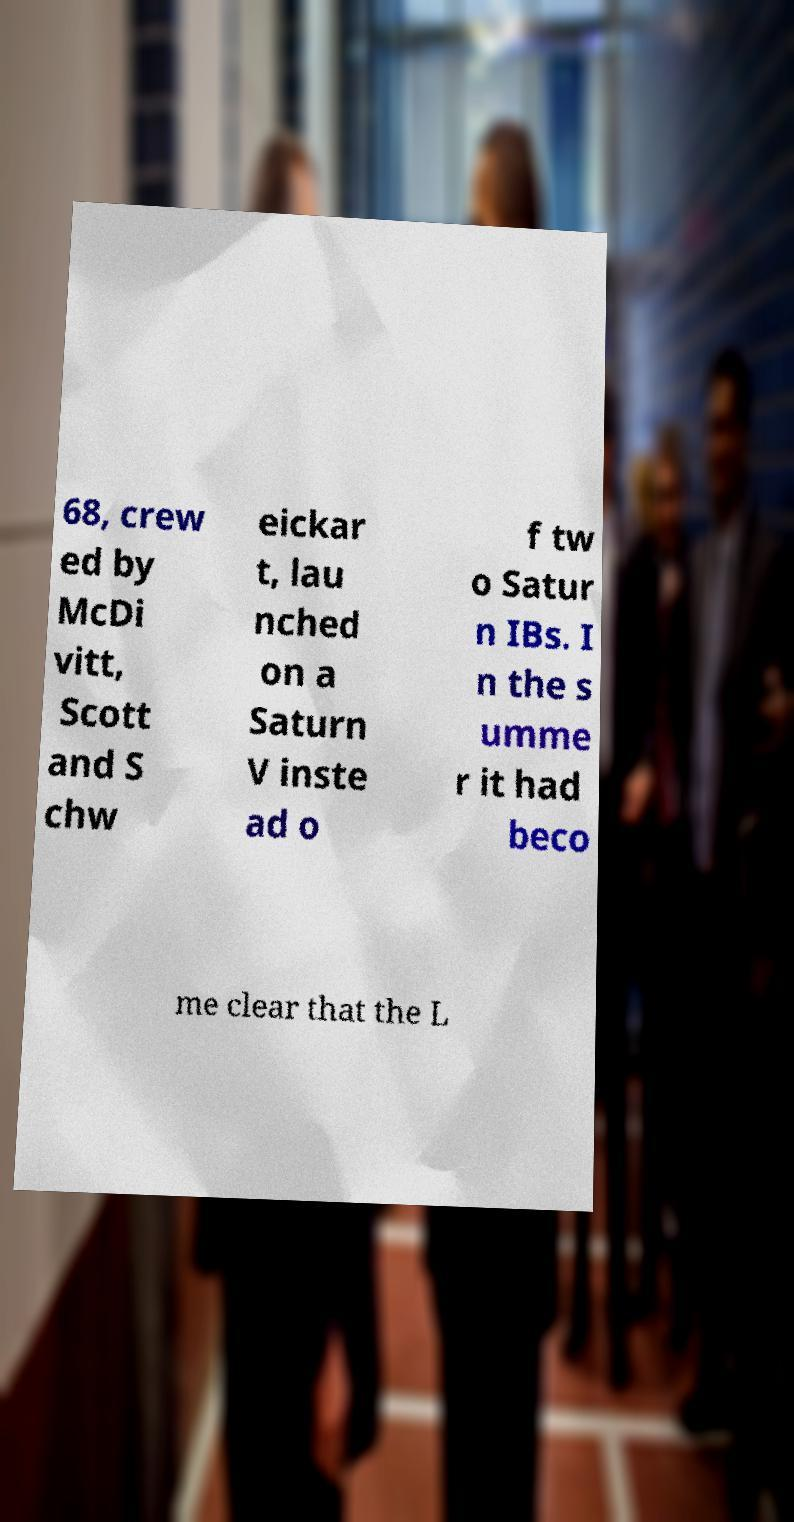Can you accurately transcribe the text from the provided image for me? 68, crew ed by McDi vitt, Scott and S chw eickar t, lau nched on a Saturn V inste ad o f tw o Satur n IBs. I n the s umme r it had beco me clear that the L 